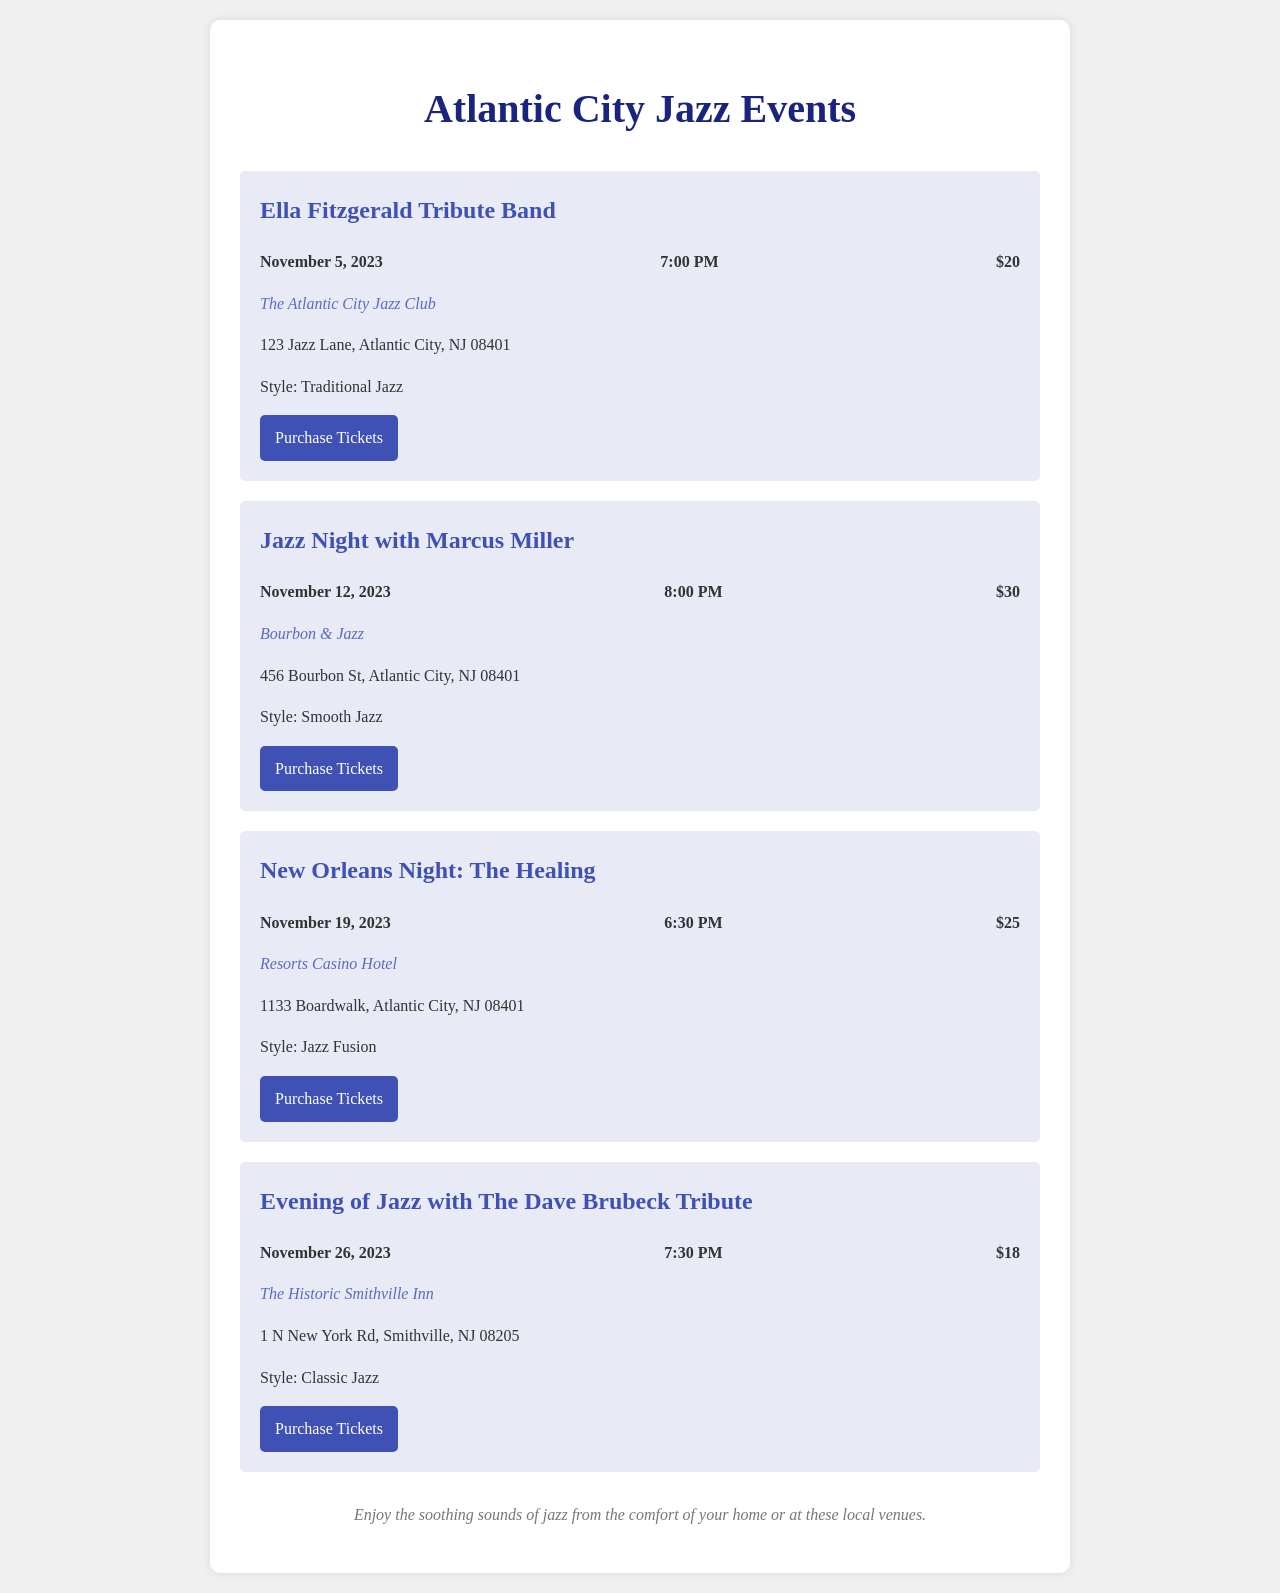What is the title of the event on November 5, 2023? The title of the event is mentioned in the event details, which is "Ella Fitzgerald Tribute Band."
Answer: Ella Fitzgerald Tribute Band What venue is hosting the Jazz Night with Marcus Miller? The venue is provided in the event details for this specific event, which is "Bourbon & Jazz."
Answer: Bourbon & Jazz How much are the tickets for the Evening of Jazz with The Dave Brubeck Tribute? The ticket price is listed in the event details, which shows the price as "$18."
Answer: $18 What style of music will be featured on November 19, 2023? The style of music is mentioned in the event description, which is "Jazz Fusion."
Answer: Jazz Fusion What time does the Ella Fitzgerald Tribute Band event start? The start time is indicated in the event details, which is "7:00 PM."
Answer: 7:00 PM Which event has the highest ticket price? The ticket prices for each event need to be compared to determine the highest, which is $30 for "Jazz Night with Marcus Miller."
Answer: $30 Where is the Resorts Casino Hotel located? The location is mentioned in the event details, specifically stating "1133 Boardwalk, Atlantic City, NJ 08401."
Answer: 1133 Boardwalk, Atlantic City, NJ 08401 What is the date of the New Orleans Night: The Healing concert? The date is specified in the event details, which is "November 19, 2023."
Answer: November 19, 2023 How many jazz events are listed in the document? The total count of the events listed in the document needs to be determined, which shows there are four events.
Answer: Four 